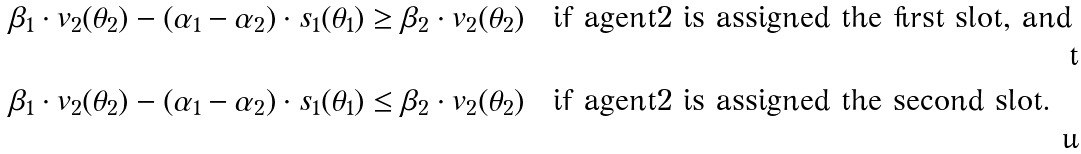<formula> <loc_0><loc_0><loc_500><loc_500>\beta _ { 1 } \cdot v _ { 2 } ( \theta _ { 2 } ) - ( \alpha _ { 1 } - \alpha _ { 2 } ) \cdot s _ { 1 } ( \theta _ { 1 } ) & \geq \beta _ { 2 } \cdot v _ { 2 } ( \theta _ { 2 } ) \quad \text {if agent$2$ is assigned the first slot, and} \\ \beta _ { 1 } \cdot v _ { 2 } ( \theta _ { 2 } ) - ( \alpha _ { 1 } - \alpha _ { 2 } ) \cdot s _ { 1 } ( \theta _ { 1 } ) & \leq \beta _ { 2 } \cdot v _ { 2 } ( \theta _ { 2 } ) \quad \text {if agent$2$ is assigned the second slot.}</formula> 